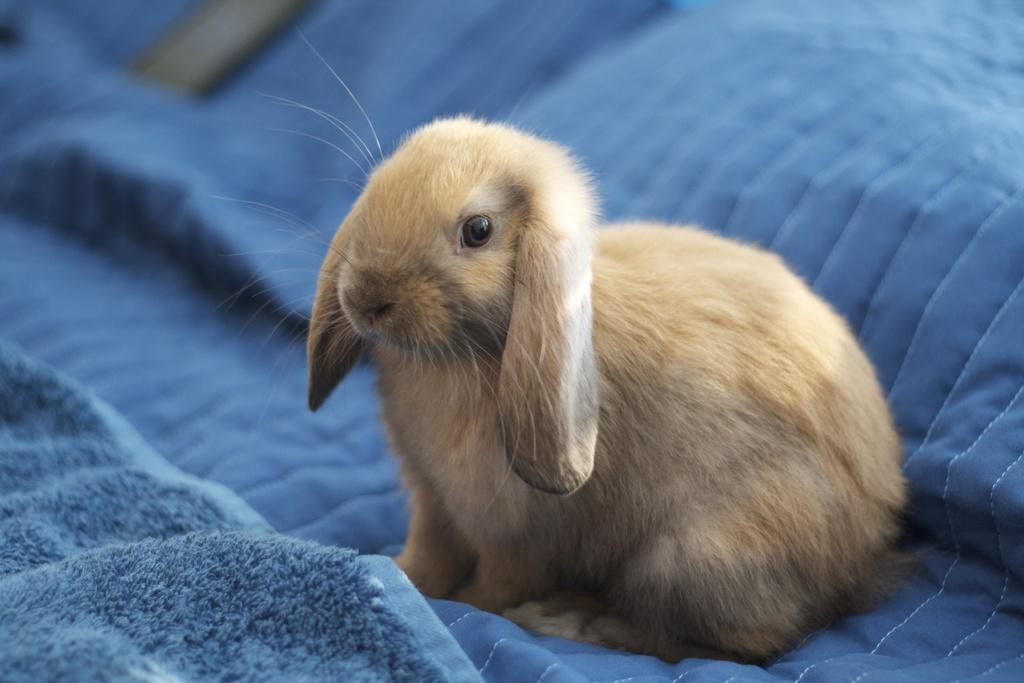What animal is present in the image? There is a rabbit in the image. Where is the rabbit located? The rabbit is sitting on a blanket. What color is the blanket? The blanket is blue in color. What type of engine is powering the coach in the image? There is no coach or engine present in the image; it features a rabbit sitting on a blue blanket. What kind of paste is being used by the rabbit in the image? There is no paste present in the image; it features a rabbit sitting on a blue blanket. 